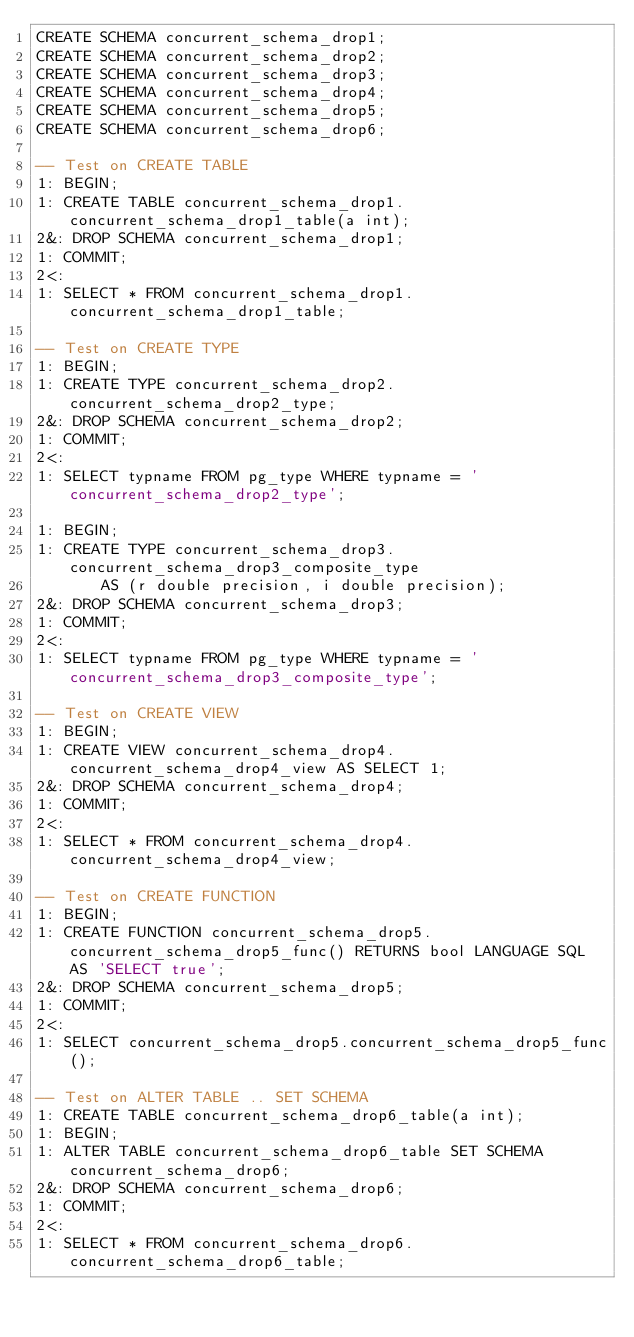Convert code to text. <code><loc_0><loc_0><loc_500><loc_500><_SQL_>CREATE SCHEMA concurrent_schema_drop1;
CREATE SCHEMA concurrent_schema_drop2;
CREATE SCHEMA concurrent_schema_drop3;
CREATE SCHEMA concurrent_schema_drop4;
CREATE SCHEMA concurrent_schema_drop5;
CREATE SCHEMA concurrent_schema_drop6;

-- Test on CREATE TABLE
1: BEGIN;
1: CREATE TABLE concurrent_schema_drop1.concurrent_schema_drop1_table(a int);
2&: DROP SCHEMA concurrent_schema_drop1;
1: COMMIT;
2<:
1: SELECT * FROM concurrent_schema_drop1.concurrent_schema_drop1_table;

-- Test on CREATE TYPE
1: BEGIN;
1: CREATE TYPE concurrent_schema_drop2.concurrent_schema_drop2_type;
2&: DROP SCHEMA concurrent_schema_drop2;
1: COMMIT;
2<:
1: SELECT typname FROM pg_type WHERE typname = 'concurrent_schema_drop2_type';

1: BEGIN;
1: CREATE TYPE concurrent_schema_drop3.concurrent_schema_drop3_composite_type
       AS (r double precision, i double precision);
2&: DROP SCHEMA concurrent_schema_drop3;
1: COMMIT;
2<:
1: SELECT typname FROM pg_type WHERE typname = 'concurrent_schema_drop3_composite_type';

-- Test on CREATE VIEW
1: BEGIN;
1: CREATE VIEW concurrent_schema_drop4.concurrent_schema_drop4_view AS SELECT 1;
2&: DROP SCHEMA concurrent_schema_drop4;
1: COMMIT;
2<:
1: SELECT * FROM concurrent_schema_drop4.concurrent_schema_drop4_view;

-- Test on CREATE FUNCTION
1: BEGIN;
1: CREATE FUNCTION concurrent_schema_drop5.concurrent_schema_drop5_func() RETURNS bool LANGUAGE SQL AS 'SELECT true';
2&: DROP SCHEMA concurrent_schema_drop5;
1: COMMIT;
2<:
1: SELECT concurrent_schema_drop5.concurrent_schema_drop5_func();

-- Test on ALTER TABLE .. SET SCHEMA
1: CREATE TABLE concurrent_schema_drop6_table(a int);
1: BEGIN;
1: ALTER TABLE concurrent_schema_drop6_table SET SCHEMA concurrent_schema_drop6;
2&: DROP SCHEMA concurrent_schema_drop6;
1: COMMIT;
2<:
1: SELECT * FROM concurrent_schema_drop6.concurrent_schema_drop6_table;
</code> 